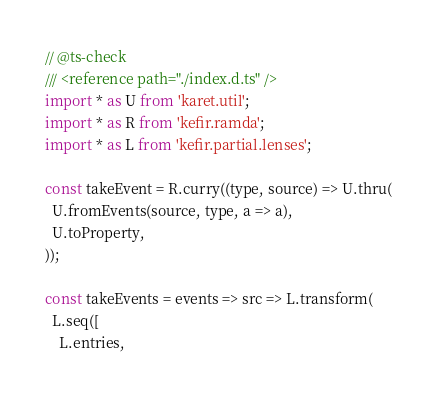<code> <loc_0><loc_0><loc_500><loc_500><_JavaScript_>// @ts-check
/// <reference path="./index.d.ts" />
import * as U from 'karet.util';
import * as R from 'kefir.ramda';
import * as L from 'kefir.partial.lenses';

const takeEvent = R.curry((type, source) => U.thru(
  U.fromEvents(source, type, a => a),
  U.toProperty,
));

const takeEvents = events => src => L.transform(
  L.seq([
    L.entries,</code> 